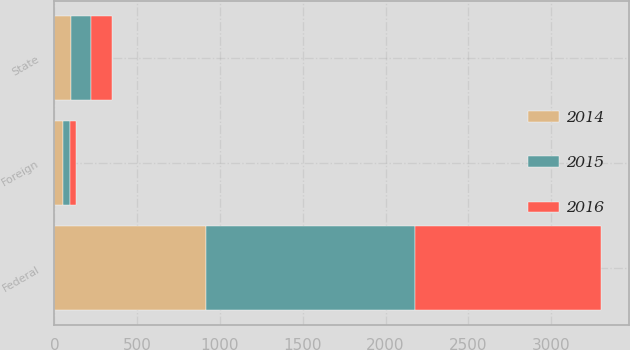Convert chart. <chart><loc_0><loc_0><loc_500><loc_500><stacked_bar_chart><ecel><fcel>Federal<fcel>State<fcel>Foreign<nl><fcel>2016<fcel>1129<fcel>125<fcel>37<nl><fcel>2015<fcel>1259<fcel>119<fcel>40<nl><fcel>2014<fcel>916<fcel>102<fcel>52<nl></chart> 